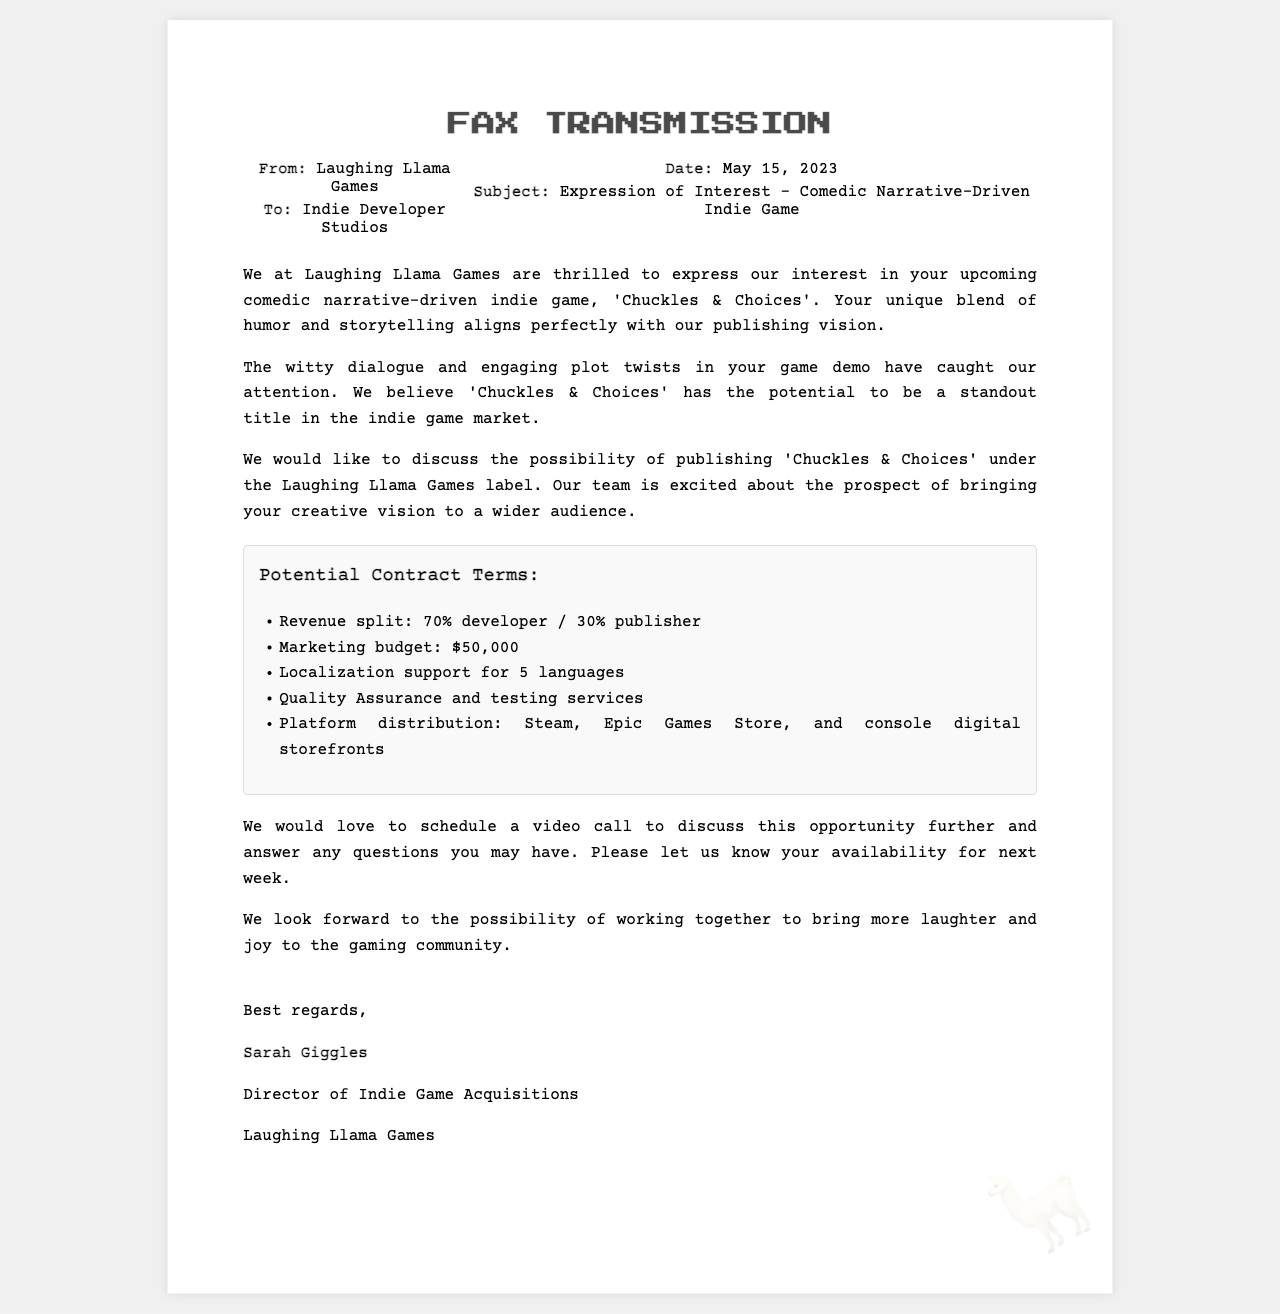What is the date of the fax? The date of the fax is provided in the document, listed as May 15, 2023.
Answer: May 15, 2023 What is the publisher's name? The publisher's name is stated in the document at the beginning, identified as Laughing Llama Games.
Answer: Laughing Llama Games What is the revenue split offered? The revenue split is detailed in the potential contract terms section of the document as 70% developer and 30% publisher.
Answer: 70% developer / 30% publisher How much is the marketing budget? The marketing budget is listed under the potential contract terms section of the document as $50,000.
Answer: $50,000 Which platforms are included for distribution? The document mentions Steam, Epic Games Store, and console digital storefronts as platforms for distribution in the potential contract terms.
Answer: Steam, Epic Games Store, and console digital storefronts What is the subject of the fax? The subject of the fax is clearly indicated in the header of the document, referring to an expression of interest regarding a specific game.
Answer: Expression of Interest - Comedic Narrative-Driven Indie Game Who is the director of indie game acquisitions? The document provides the name of the director, mentioned at the end in the signature section as the individual who wrote the fax.
Answer: Sarah Giggles What localization support is offered? The potential contract terms specify that localization support for five languages will be provided, as outlined in the document.
Answer: 5 languages 